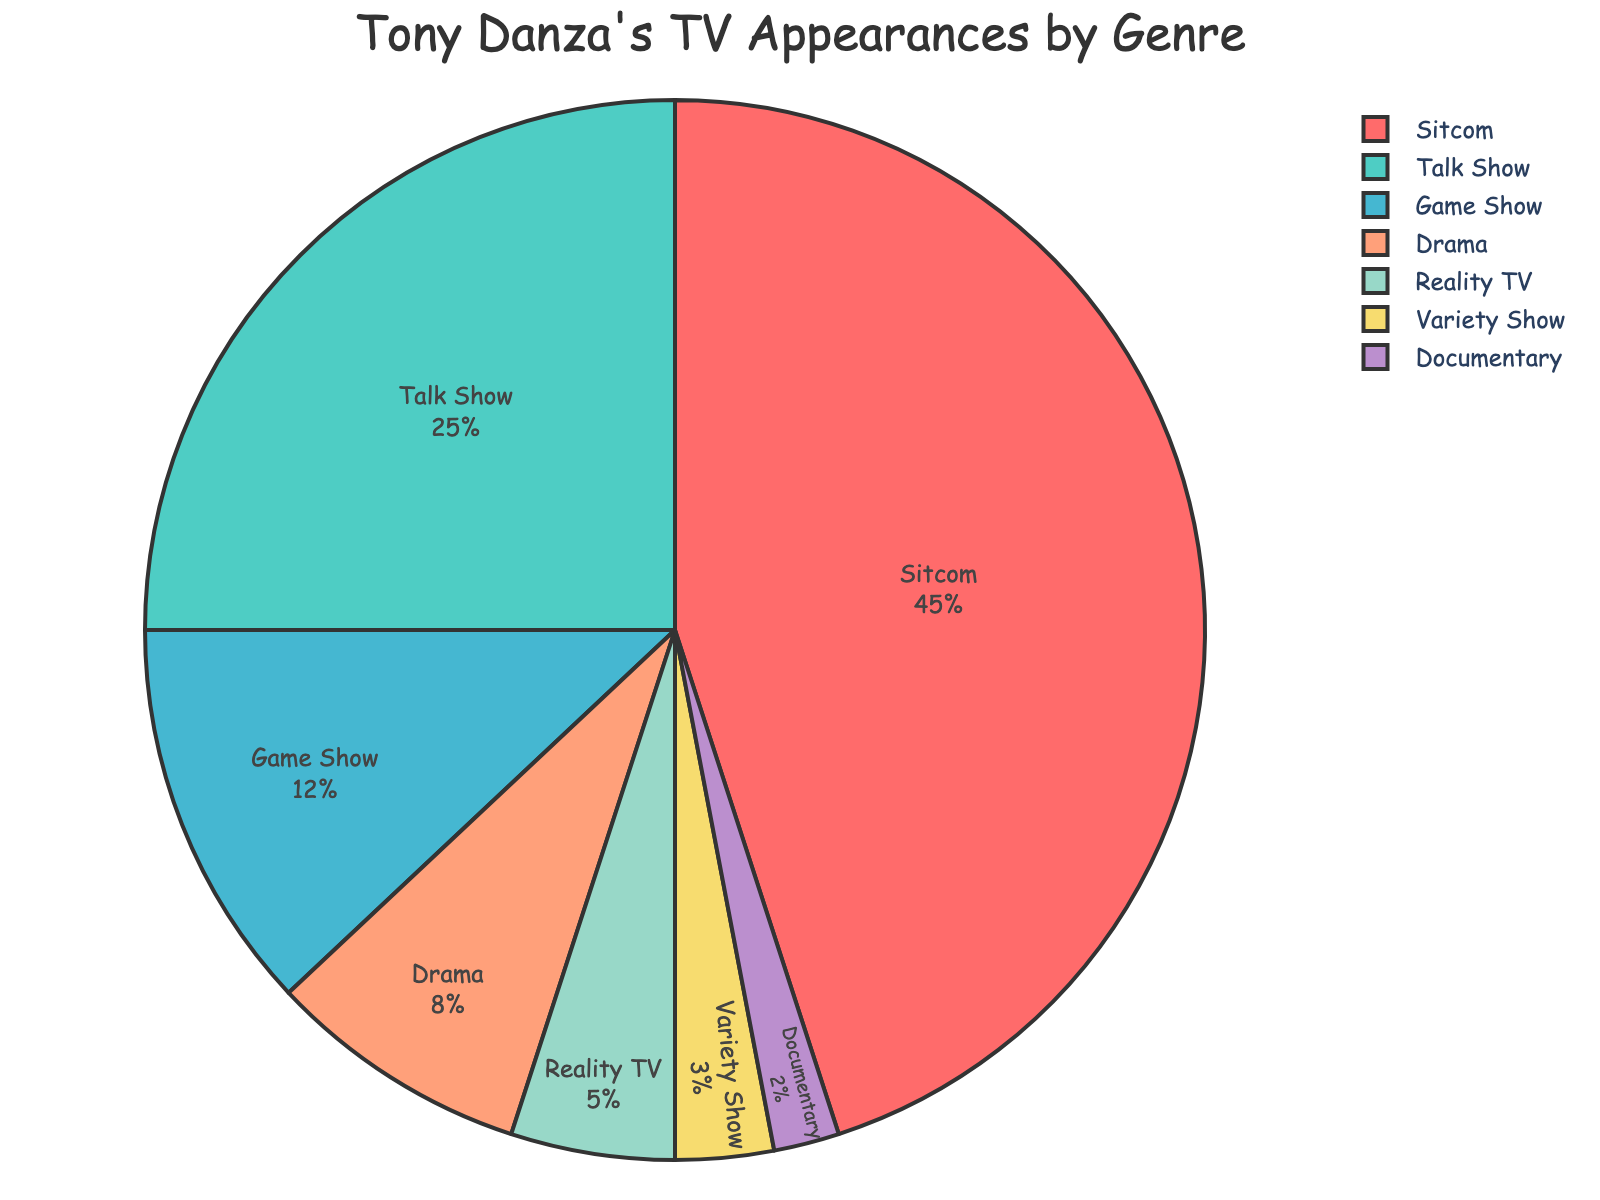What percentage of Tony Danza's TV appearances were in Reality TV and Variety Shows combined? First, identify the percentages for Reality TV (5%) and Variety Shows (3%) in the pie chart. Then, sum these values: 5% + 3% = 8%.
Answer: 8% Which genre has the second-highest percentage of Tony Danza's TV appearances? From the pie chart, Sitcom is the highest with 45%, and the second highest is Talk Shows with 25%.
Answer: Talk Show By how much does the percentage of Sitcom appearances exceed Documentary appearances? The percentage for Sitcoms is 45% and for Documentaries is 2%. The difference is 45% - 2% = 43%.
Answer: 43% How many genres have a percentage greater than 10%? Identify the percentages from the pie chart. Sitcom (45%), Talk Show (25%), and Game Show (12%) each have percentages greater than 10%. Thus, there are 3 genres.
Answer: 3 What is the average percentage of Drama, Reality TV, and Documentary appearances? Identify the percentages: Drama (8%), Reality TV (5%), Documentary (2%). Sum these: 8% + 5% + 2% = 15%. Divide by the number of genres: 15% / 3 = 5%.
Answer: 5% Is the percentage of Talk Show appearances more than double the percentage of Game Show appearances? The percentage for Talk Shows is 25% and for Game Shows is 12%. Double 12% is 24%, and 25% is more than 24%.
Answer: Yes Which visual attribute does the Sitcom segment of the pie chart have? In the pie chart, the Sitcom segment is identified by a distinct color (red) and its size is the largest.
Answer: Largest, red Which two genres collectively account for the smallest percentage of Tony Danza's TV appearances? The percentages for the least genres are Documentary (2%) and Variety Show (3%). Together, they account for a small percentage which is 5%.
Answer: Variety Show, Documentary What genre does the light blue segment of the pie chart represent? The light blue segment in the pie chart represents the percentage for Game Shows, which is 12%.
Answer: Game Show What is the combined percentage of Tony Danza's TV appearances in genres that individually account for less than 10% each? Identify the percentages for genres below 10%: Drama (8%), Reality TV (5%), Variety Show (3%), Documentary (2%). Sum these: 8% + 5% + 3% + 2% = 18%.
Answer: 18% 